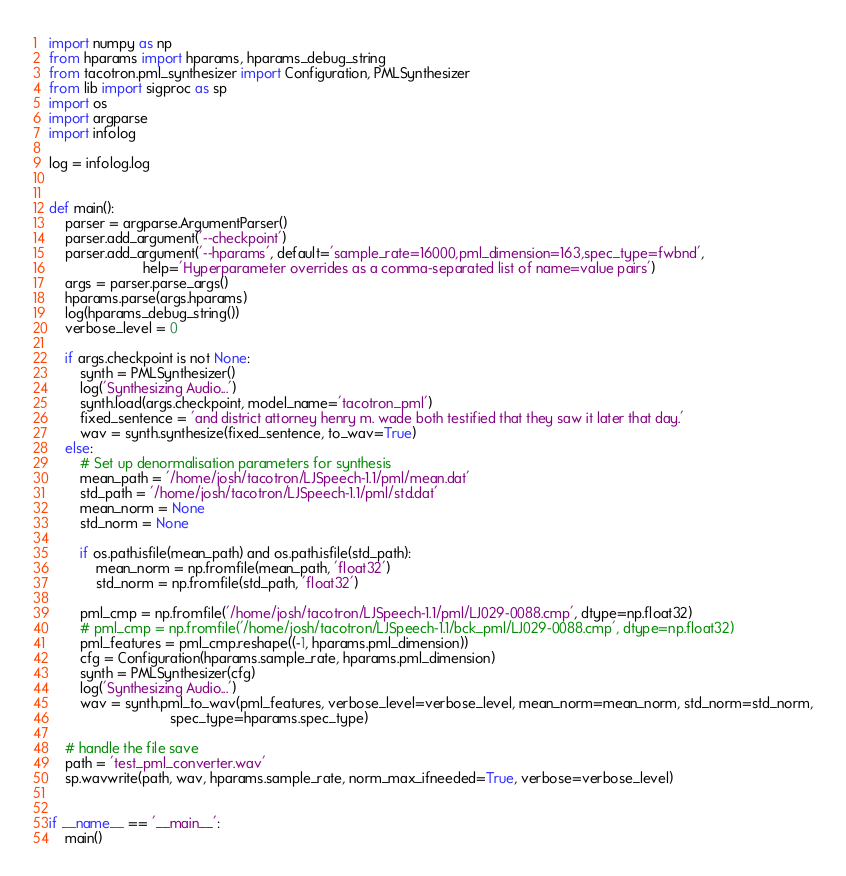<code> <loc_0><loc_0><loc_500><loc_500><_Python_>import numpy as np
from hparams import hparams, hparams_debug_string
from tacotron.pml_synthesizer import Configuration, PMLSynthesizer
from lib import sigproc as sp
import os
import argparse
import infolog

log = infolog.log


def main():
    parser = argparse.ArgumentParser()
    parser.add_argument('--checkpoint')
    parser.add_argument('--hparams', default='sample_rate=16000,pml_dimension=163,spec_type=fwbnd',
                        help='Hyperparameter overrides as a comma-separated list of name=value pairs')
    args = parser.parse_args()
    hparams.parse(args.hparams)
    log(hparams_debug_string())
    verbose_level = 0

    if args.checkpoint is not None:
        synth = PMLSynthesizer()
        log('Synthesizing Audio...')
        synth.load(args.checkpoint, model_name='tacotron_pml')
        fixed_sentence = 'and district attorney henry m. wade both testified that they saw it later that day.'
        wav = synth.synthesize(fixed_sentence, to_wav=True)
    else:
        # Set up denormalisation parameters for synthesis
        mean_path = '/home/josh/tacotron/LJSpeech-1.1/pml/mean.dat'
        std_path = '/home/josh/tacotron/LJSpeech-1.1/pml/std.dat'
        mean_norm = None
        std_norm = None

        if os.path.isfile(mean_path) and os.path.isfile(std_path):
            mean_norm = np.fromfile(mean_path, 'float32')
            std_norm = np.fromfile(std_path, 'float32')

        pml_cmp = np.fromfile('/home/josh/tacotron/LJSpeech-1.1/pml/LJ029-0088.cmp', dtype=np.float32)
        # pml_cmp = np.fromfile('/home/josh/tacotron/LJSpeech-1.1/bck_pml/LJ029-0088.cmp', dtype=np.float32)
        pml_features = pml_cmp.reshape((-1, hparams.pml_dimension))
        cfg = Configuration(hparams.sample_rate, hparams.pml_dimension)
        synth = PMLSynthesizer(cfg)
        log('Synthesizing Audio...')
        wav = synth.pml_to_wav(pml_features, verbose_level=verbose_level, mean_norm=mean_norm, std_norm=std_norm,
                               spec_type=hparams.spec_type)

    # handle the file save
    path = 'test_pml_converter.wav'
    sp.wavwrite(path, wav, hparams.sample_rate, norm_max_ifneeded=True, verbose=verbose_level)


if __name__ == '__main__':
    main()
</code> 